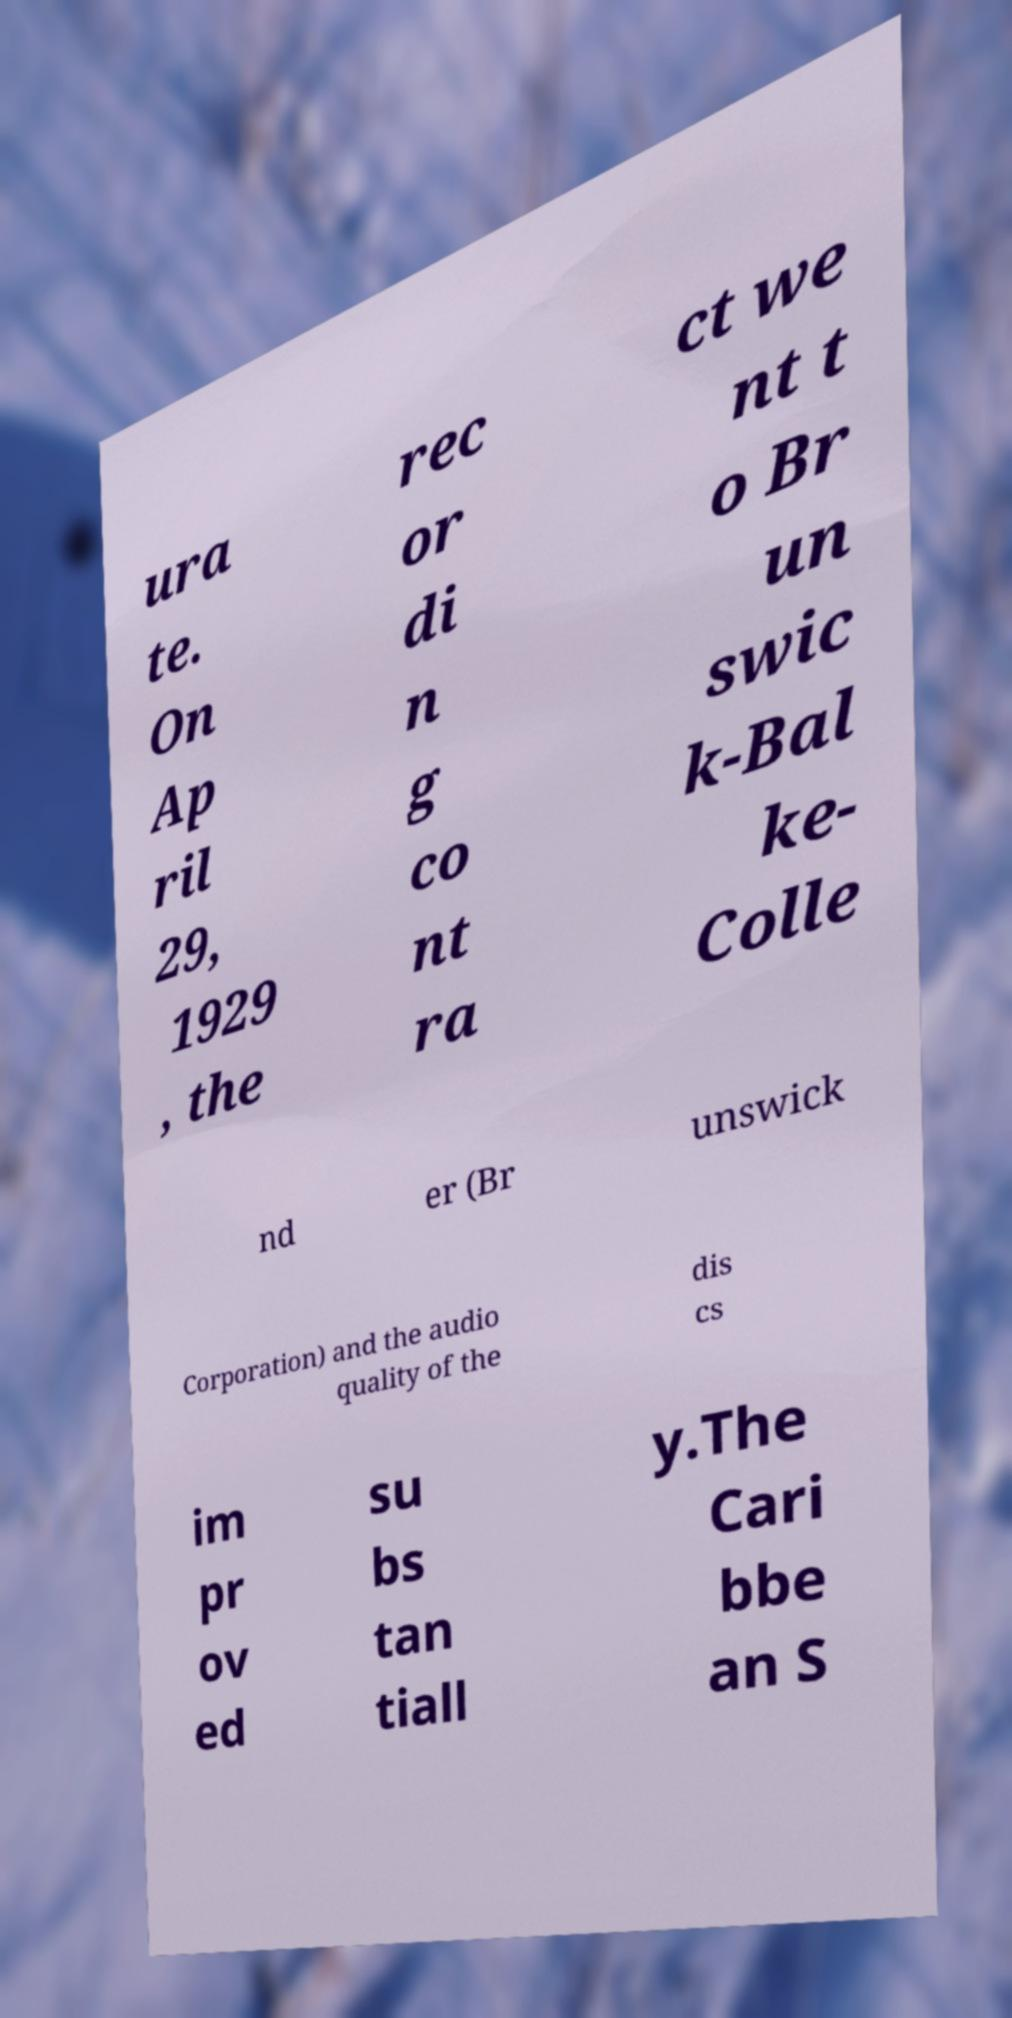Can you accurately transcribe the text from the provided image for me? ura te. On Ap ril 29, 1929 , the rec or di n g co nt ra ct we nt t o Br un swic k-Bal ke- Colle nd er (Br unswick Corporation) and the audio quality of the dis cs im pr ov ed su bs tan tiall y.The Cari bbe an S 